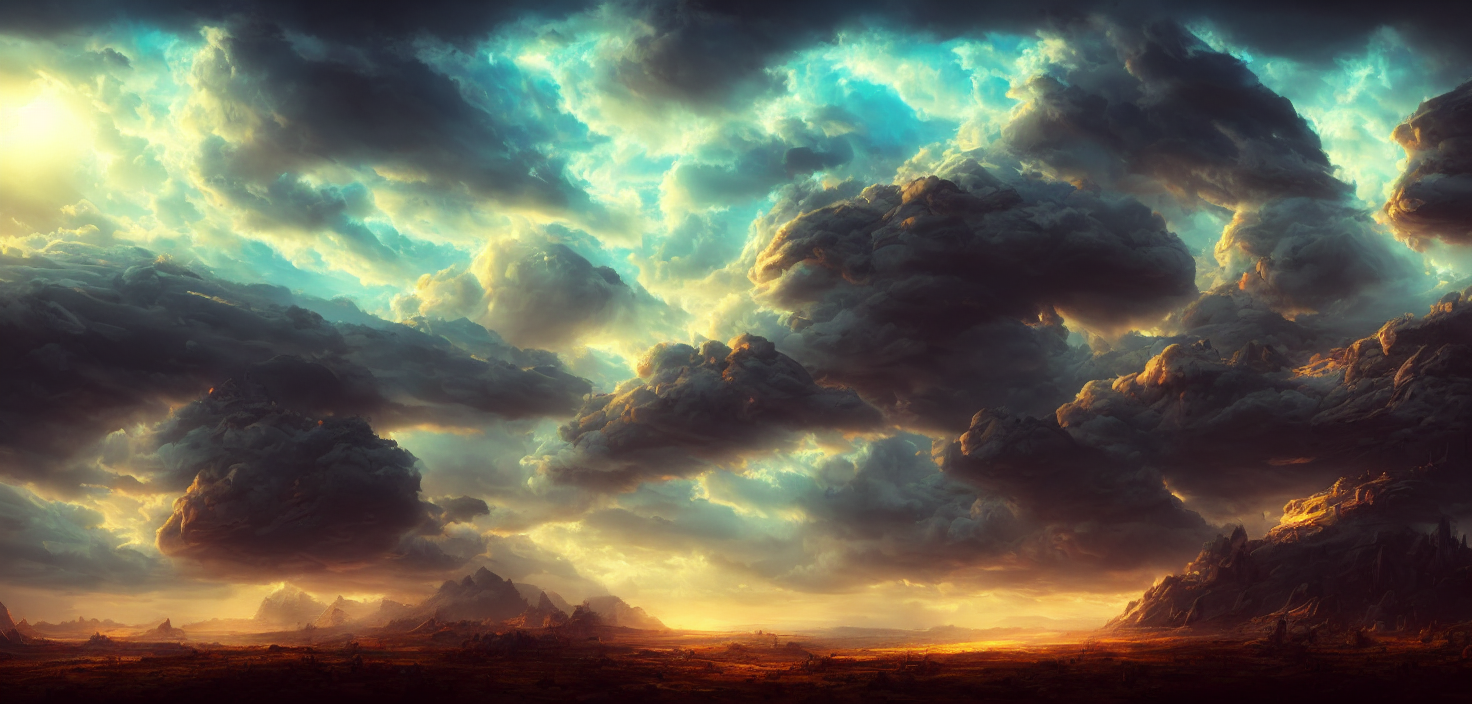How does the lighting in the image affect the overall mood? The interplay of light and shadow dramatically impacts the image's mood, creating a surreal and almost otherworldly atmosphere. The sunlight filtering through the clouds illuminates parts of the landscape, giving a sense of awe and grandeur, while the darker areas add a touch of mystery and depth. 